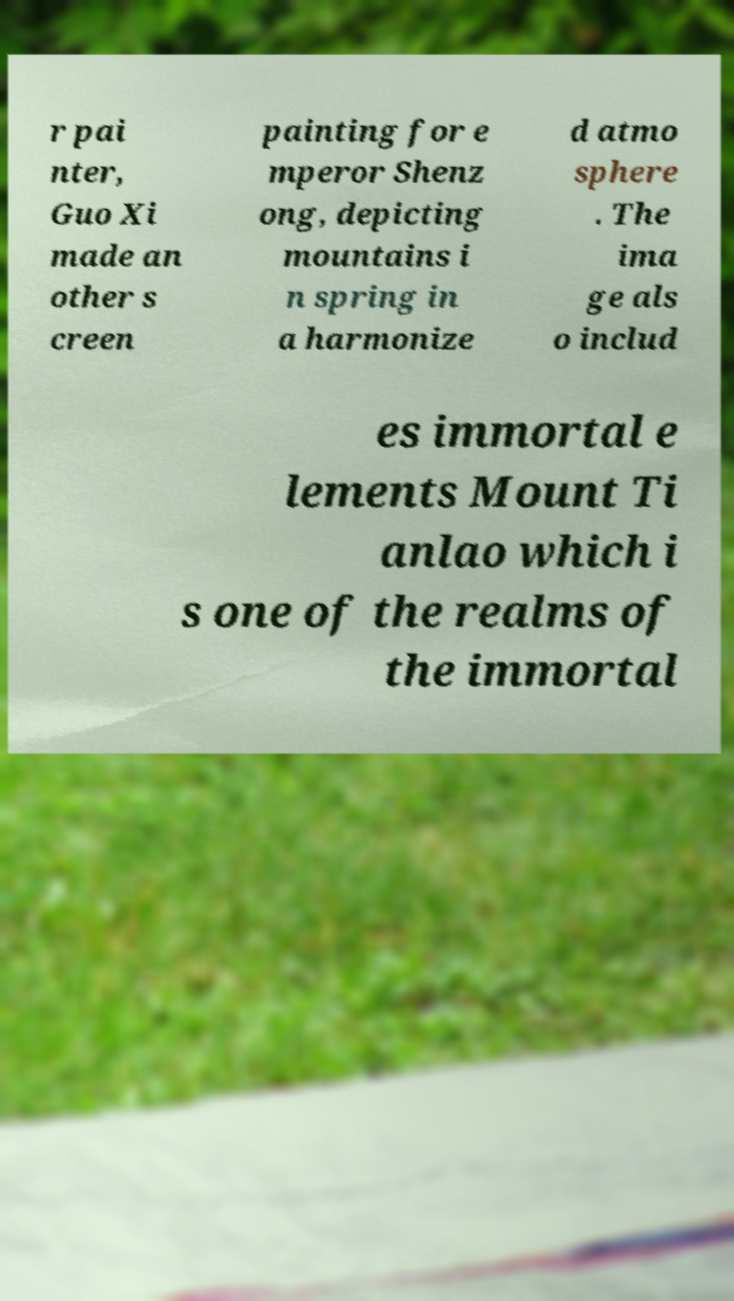I need the written content from this picture converted into text. Can you do that? r pai nter, Guo Xi made an other s creen painting for e mperor Shenz ong, depicting mountains i n spring in a harmonize d atmo sphere . The ima ge als o includ es immortal e lements Mount Ti anlao which i s one of the realms of the immortal 